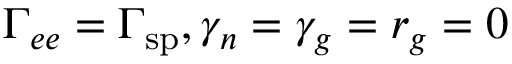Convert formula to latex. <formula><loc_0><loc_0><loc_500><loc_500>\Gamma _ { e e } = \Gamma _ { s p } , \gamma _ { n } = \gamma _ { g } = r _ { g } = 0</formula> 